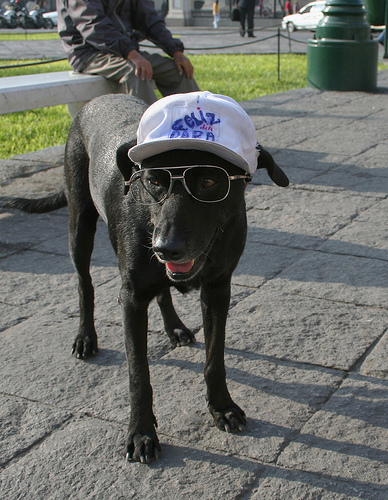How many different kinds of animals are in the photo? There is only one kind of animal in the photo, which is a dog. This adorable canine is accessorized with sunglasses and a hat, giving it a playful and humanized appearance. 